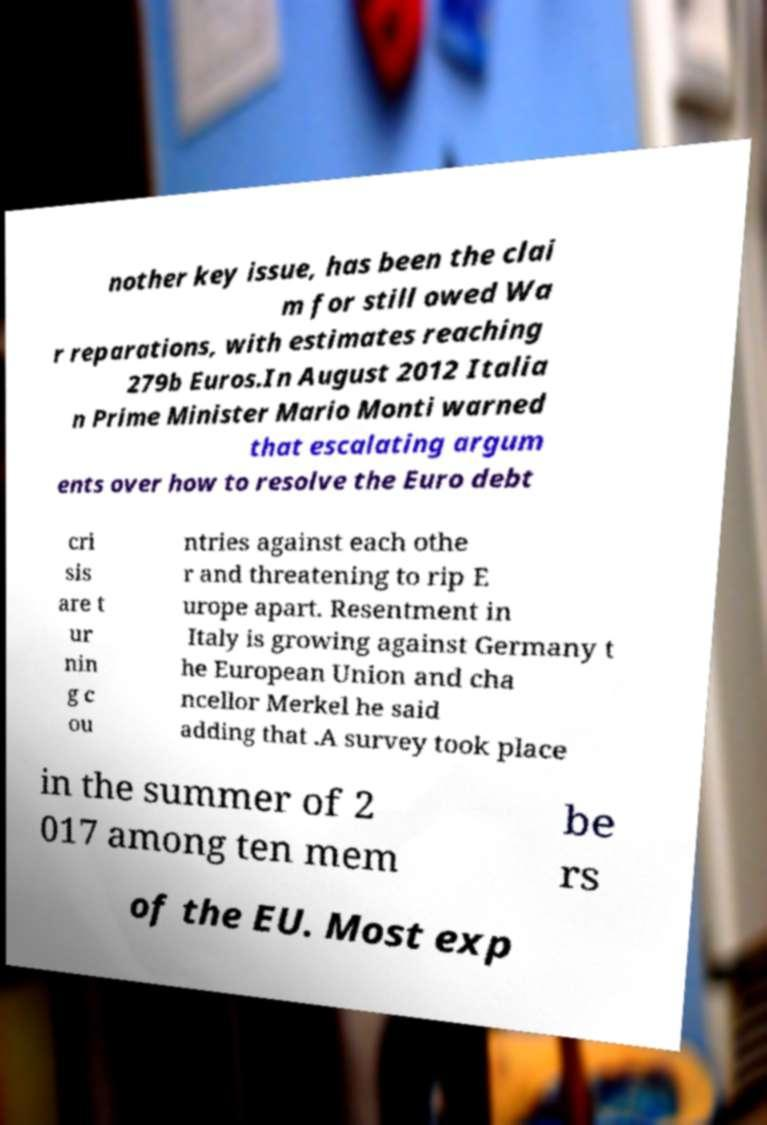For documentation purposes, I need the text within this image transcribed. Could you provide that? nother key issue, has been the clai m for still owed Wa r reparations, with estimates reaching 279b Euros.In August 2012 Italia n Prime Minister Mario Monti warned that escalating argum ents over how to resolve the Euro debt cri sis are t ur nin g c ou ntries against each othe r and threatening to rip E urope apart. Resentment in Italy is growing against Germany t he European Union and cha ncellor Merkel he said adding that .A survey took place in the summer of 2 017 among ten mem be rs of the EU. Most exp 